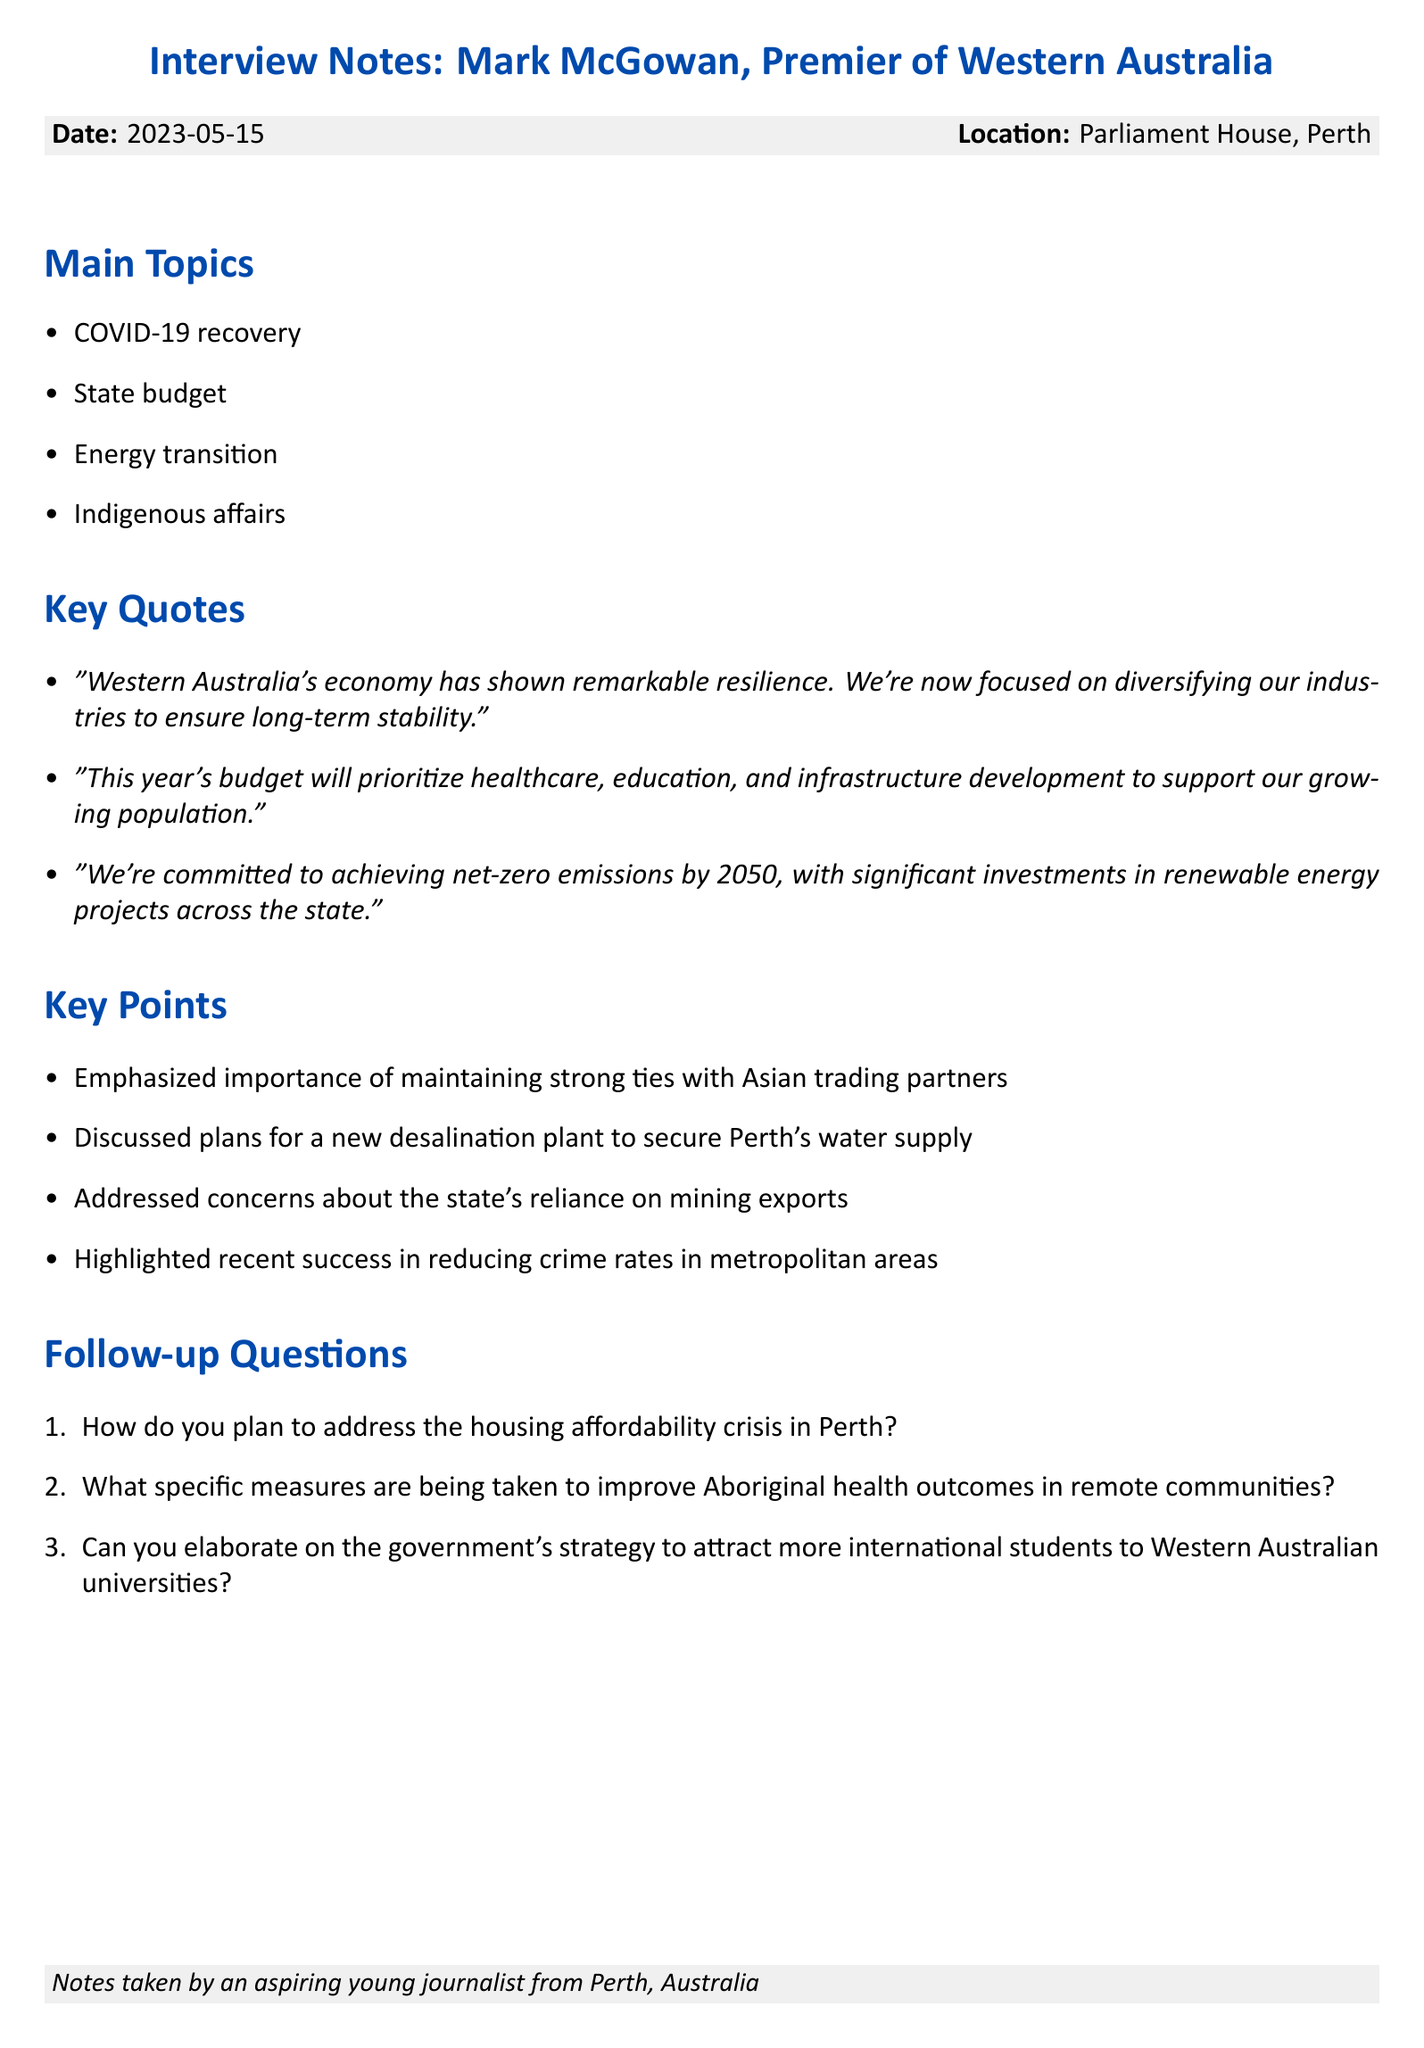What is the date of the interview? The date of the interview is clearly stated in the document.
Answer: 2023-05-15 Who is the interviewee? The document specifies the name of the person interviewed.
Answer: Mark McGowan What location was the interview conducted in? The location of the interview is mentioned in the document.
Answer: Parliament House, Perth What is the position of Mark McGowan? The position of the interviewee is provided within the document.
Answer: Premier of Western Australia How many main topics were discussed in the interview? The number of main topics is found in the main topics section.
Answer: 4 What is one of the key focuses of the state's budget according to the interview? The budget priorities are clearly listed in a quote in the document.
Answer: healthcare What is the commitment regarding net-zero emissions mentioned? The document includes specific language regarding emissions goals.
Answer: by 2050 What are significant investments being made in? This refers to a specific area of investment mentioned in the interview.
Answer: renewable energy projects Which international ties were emphasized by McGowan? The document highlights the importance of international relationships.
Answer: Asian trading partners 